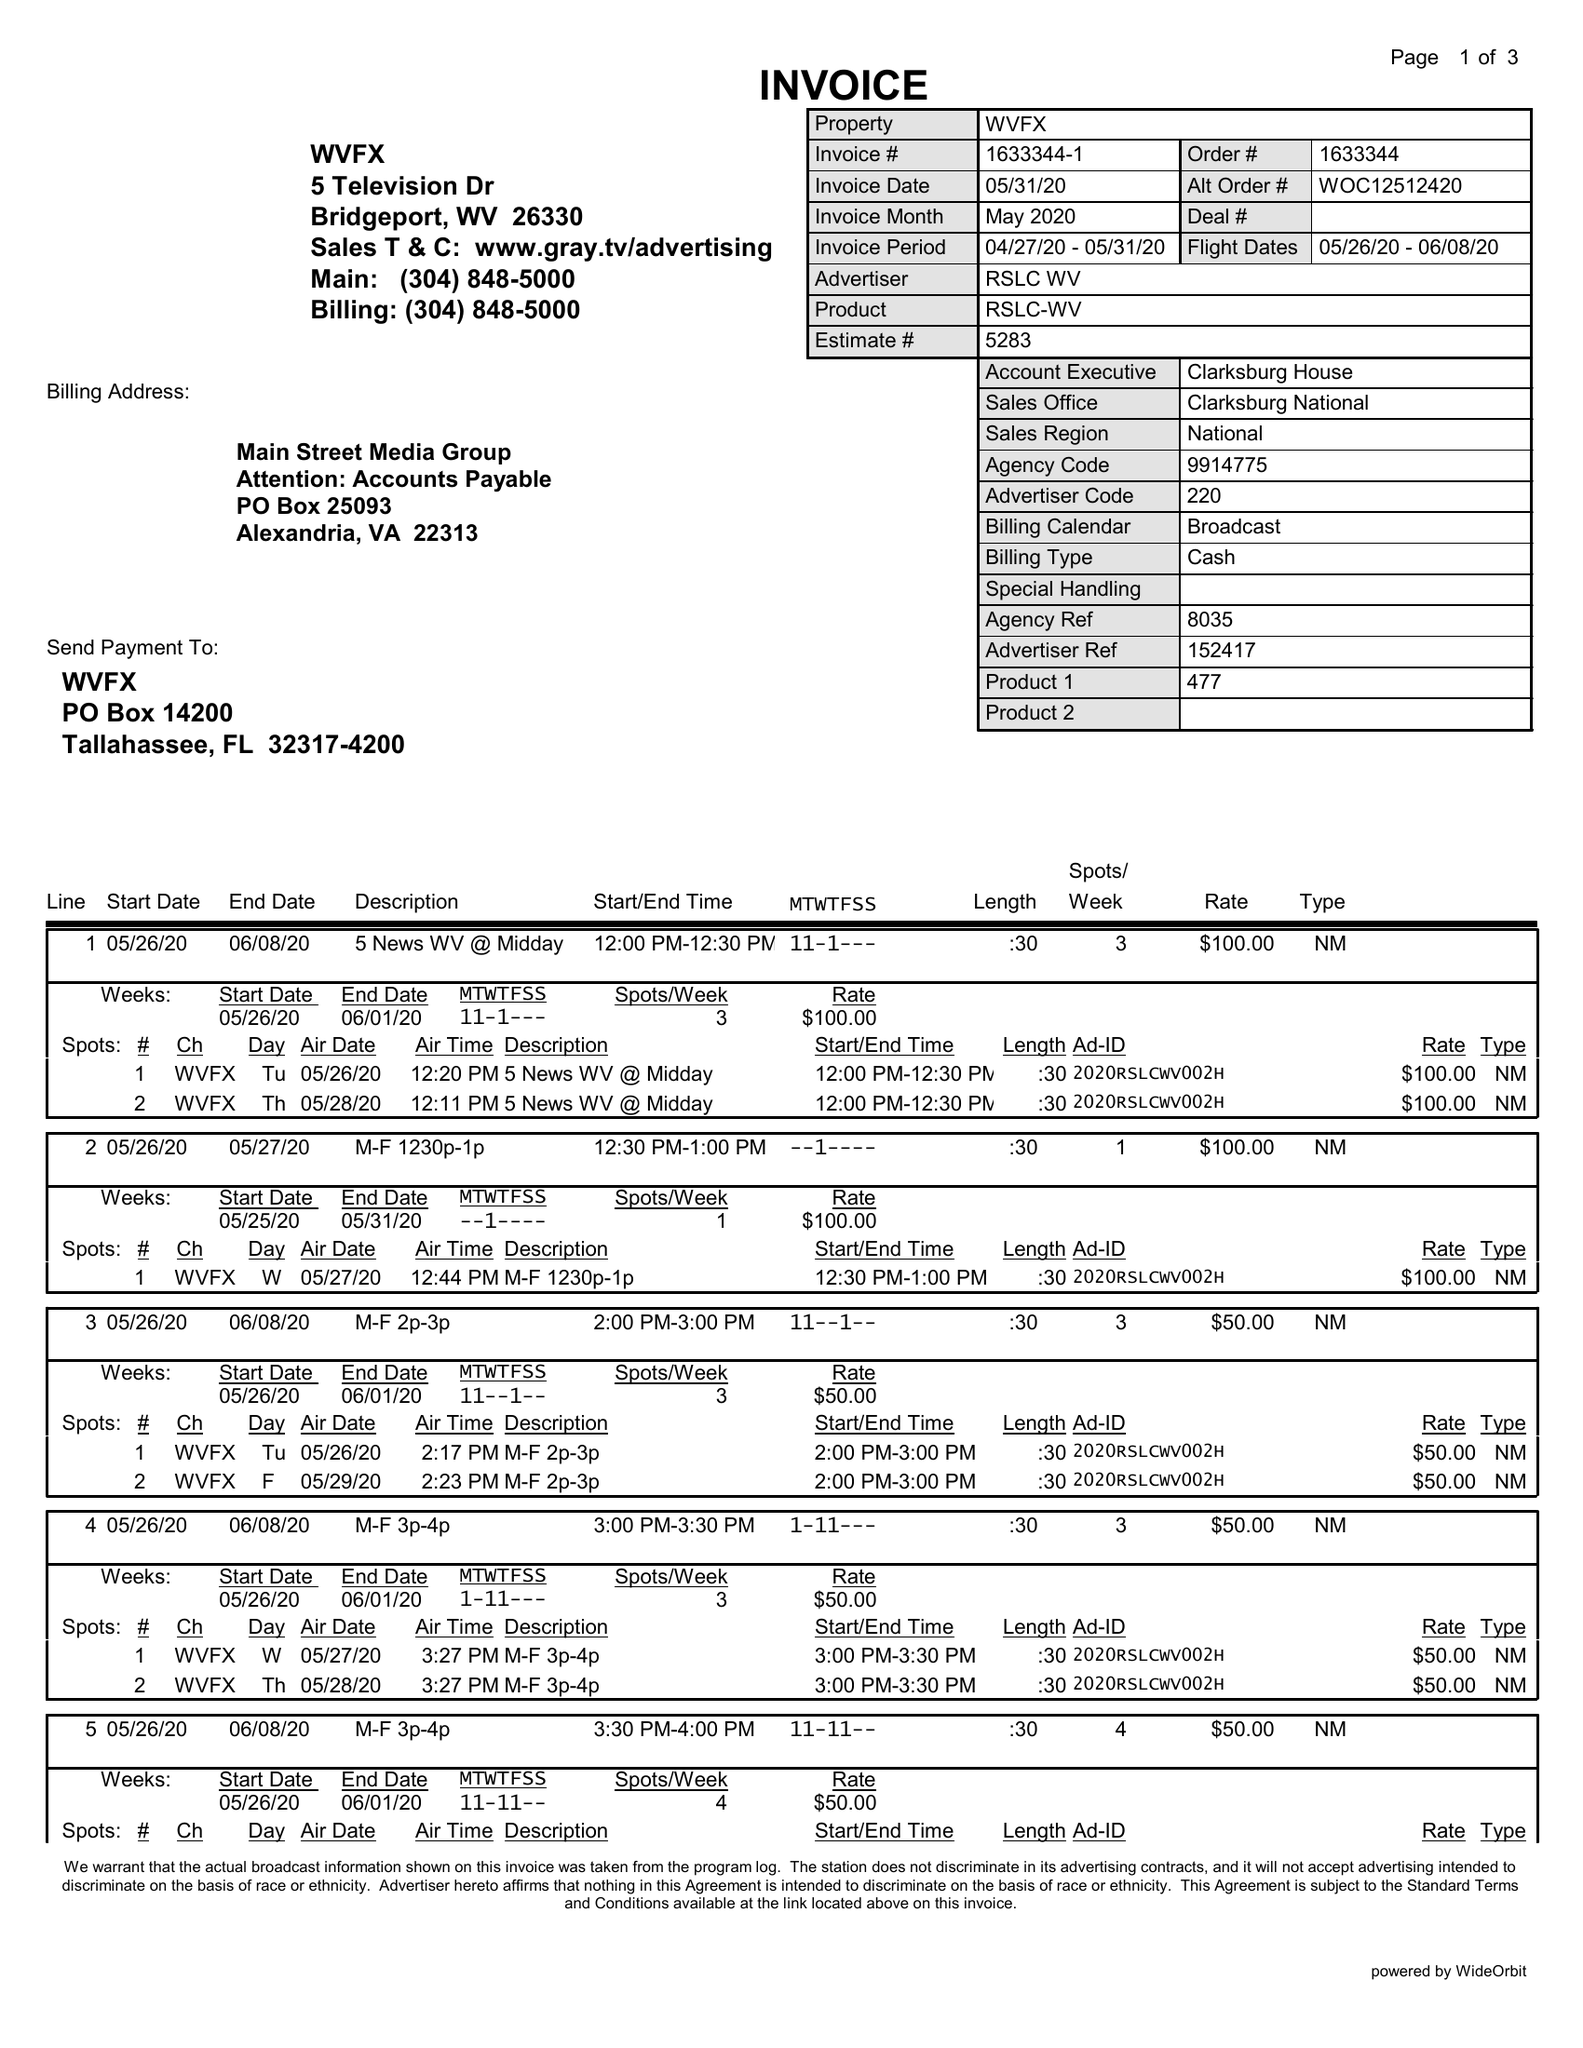What is the value for the flight_to?
Answer the question using a single word or phrase. 06/08/20 